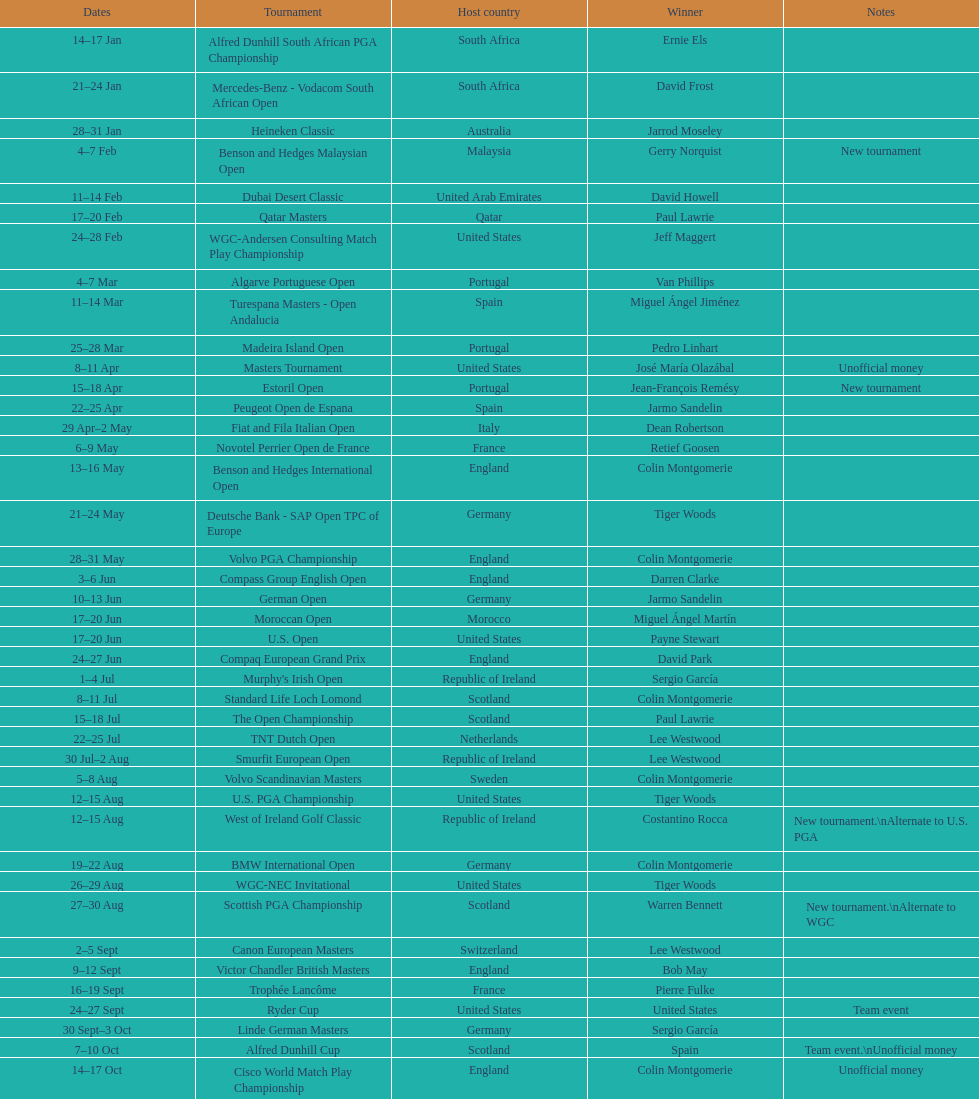Can any country claim to have in excess of 5 winners? Yes. 